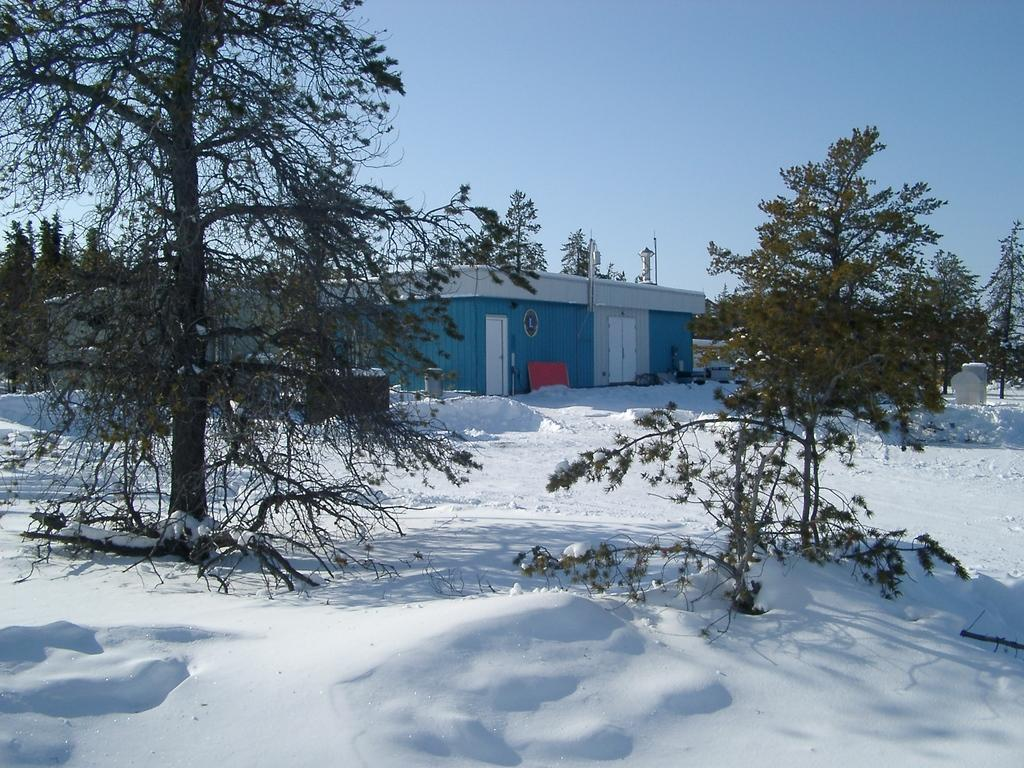What type of vegetation is present in the image? There is a group of trees in the image. What type of structure can be seen in the image? There is a building in the image. What can be seen in the background of the image? The sky is visible in the background of the image. How many rabbits can be seen playing with copper in the image? There are no rabbits or copper present in the image. What type of cemetery is visible in the image? There is no cemetery present in the image. 